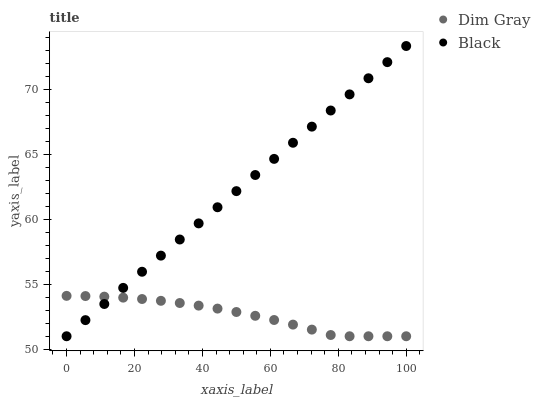Does Dim Gray have the minimum area under the curve?
Answer yes or no. Yes. Does Black have the maximum area under the curve?
Answer yes or no. Yes. Does Black have the minimum area under the curve?
Answer yes or no. No. Is Black the smoothest?
Answer yes or no. Yes. Is Dim Gray the roughest?
Answer yes or no. Yes. Is Black the roughest?
Answer yes or no. No. Does Dim Gray have the lowest value?
Answer yes or no. Yes. Does Black have the highest value?
Answer yes or no. Yes. Does Black intersect Dim Gray?
Answer yes or no. Yes. Is Black less than Dim Gray?
Answer yes or no. No. Is Black greater than Dim Gray?
Answer yes or no. No. 